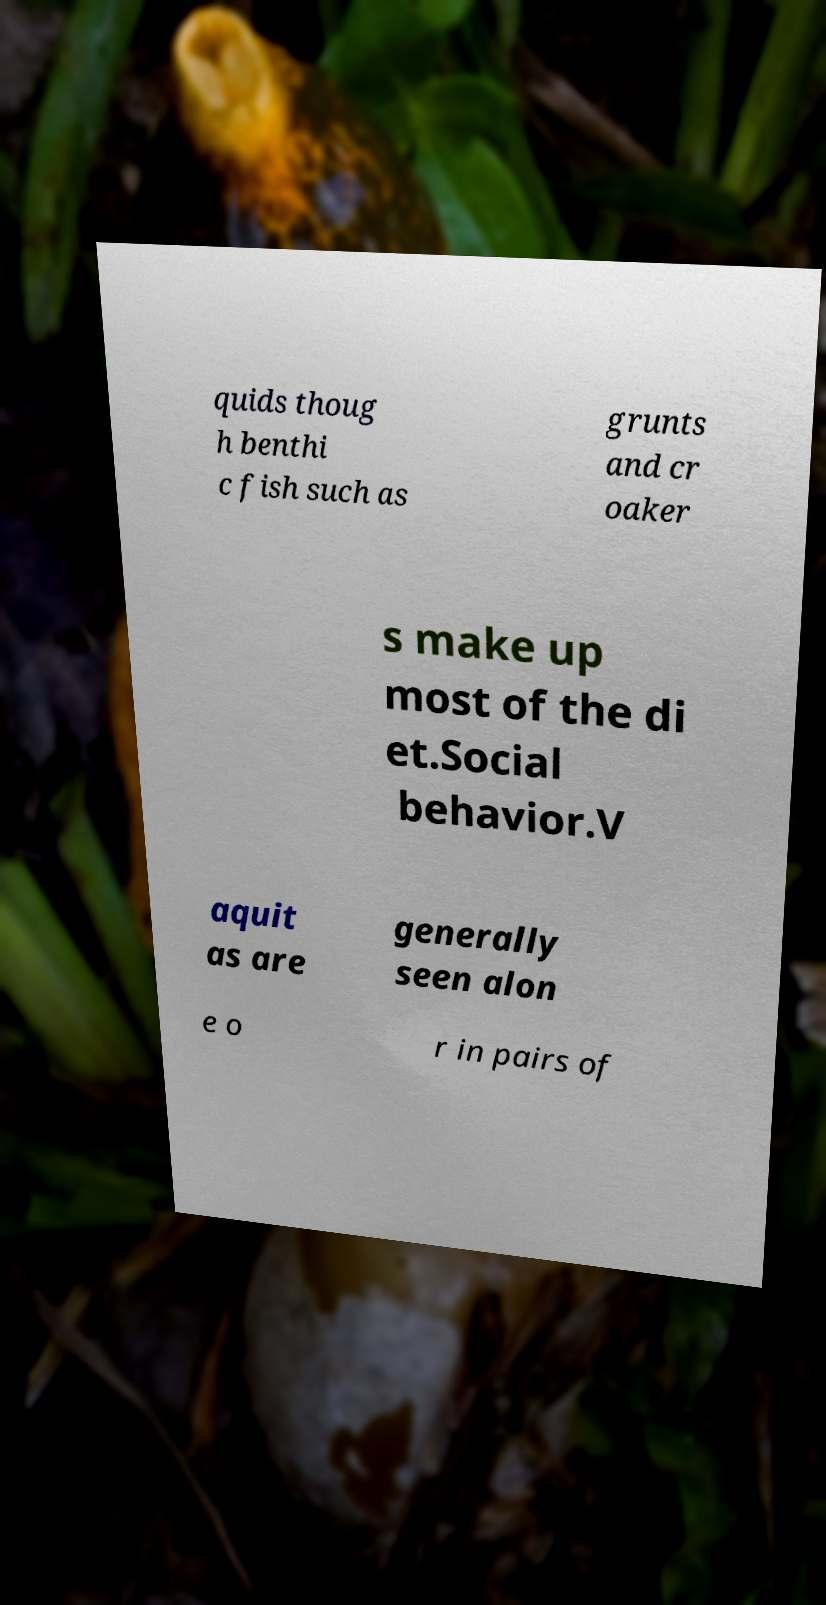Please identify and transcribe the text found in this image. quids thoug h benthi c fish such as grunts and cr oaker s make up most of the di et.Social behavior.V aquit as are generally seen alon e o r in pairs of 